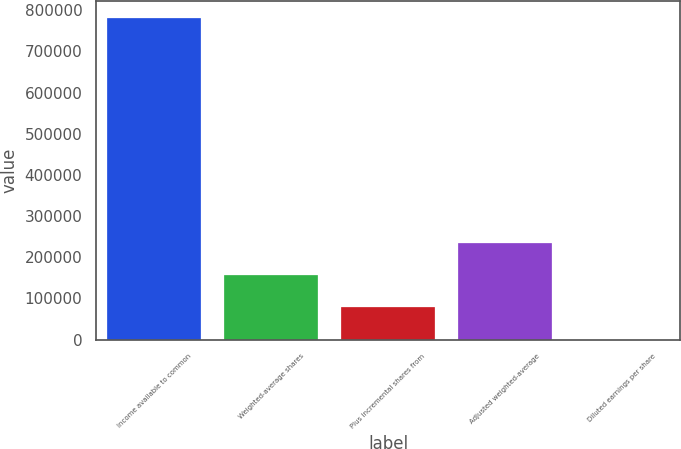<chart> <loc_0><loc_0><loc_500><loc_500><bar_chart><fcel>Income available to common<fcel>Weighted-average shares<fcel>Plus incremental shares from<fcel>Adjusted weighted-average<fcel>Diluted earnings per share<nl><fcel>782183<fcel>156442<fcel>78224.4<fcel>234660<fcel>6.73<nl></chart> 